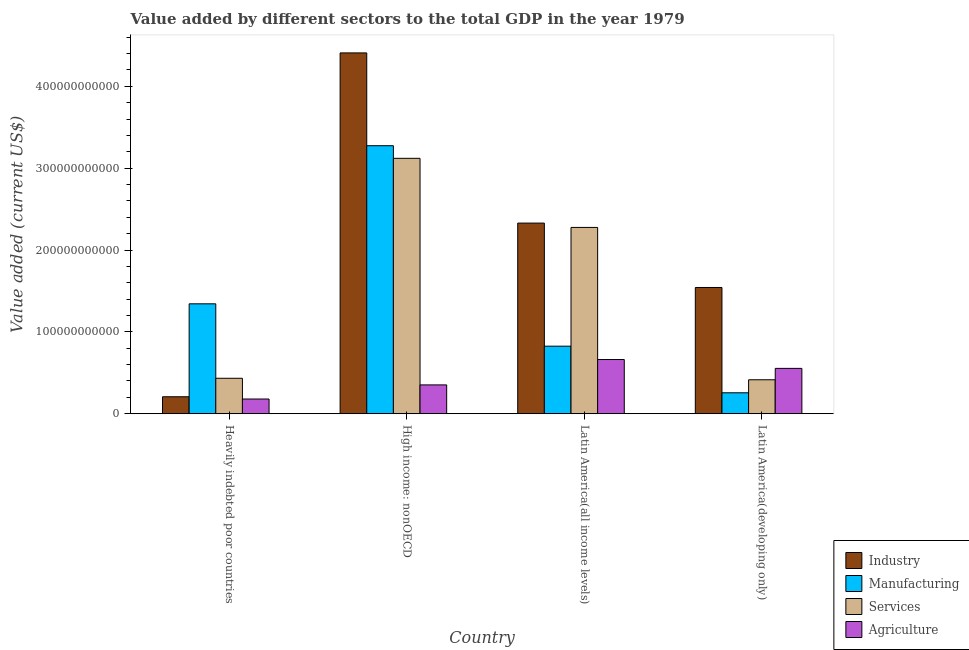How many different coloured bars are there?
Offer a terse response. 4. How many groups of bars are there?
Your answer should be very brief. 4. How many bars are there on the 4th tick from the left?
Offer a very short reply. 4. What is the label of the 3rd group of bars from the left?
Offer a terse response. Latin America(all income levels). What is the value added by industrial sector in Latin America(developing only)?
Your answer should be very brief. 1.54e+11. Across all countries, what is the maximum value added by manufacturing sector?
Your response must be concise. 3.27e+11. Across all countries, what is the minimum value added by agricultural sector?
Provide a short and direct response. 1.80e+1. In which country was the value added by industrial sector maximum?
Offer a very short reply. High income: nonOECD. In which country was the value added by industrial sector minimum?
Your response must be concise. Heavily indebted poor countries. What is the total value added by agricultural sector in the graph?
Provide a short and direct response. 1.75e+11. What is the difference between the value added by agricultural sector in High income: nonOECD and that in Latin America(developing only)?
Your answer should be compact. -2.02e+1. What is the difference between the value added by agricultural sector in Latin America(developing only) and the value added by services sector in High income: nonOECD?
Keep it short and to the point. -2.57e+11. What is the average value added by services sector per country?
Your response must be concise. 1.56e+11. What is the difference between the value added by services sector and value added by industrial sector in Heavily indebted poor countries?
Offer a very short reply. 2.26e+1. What is the ratio of the value added by services sector in Latin America(all income levels) to that in Latin America(developing only)?
Offer a very short reply. 5.48. Is the difference between the value added by services sector in High income: nonOECD and Latin America(all income levels) greater than the difference between the value added by industrial sector in High income: nonOECD and Latin America(all income levels)?
Offer a terse response. No. What is the difference between the highest and the second highest value added by manufacturing sector?
Your answer should be very brief. 1.93e+11. What is the difference between the highest and the lowest value added by industrial sector?
Offer a very short reply. 4.20e+11. In how many countries, is the value added by services sector greater than the average value added by services sector taken over all countries?
Ensure brevity in your answer.  2. Is it the case that in every country, the sum of the value added by agricultural sector and value added by manufacturing sector is greater than the sum of value added by services sector and value added by industrial sector?
Your answer should be compact. No. What does the 1st bar from the left in High income: nonOECD represents?
Keep it short and to the point. Industry. What does the 1st bar from the right in Latin America(developing only) represents?
Keep it short and to the point. Agriculture. Is it the case that in every country, the sum of the value added by industrial sector and value added by manufacturing sector is greater than the value added by services sector?
Offer a very short reply. Yes. Are all the bars in the graph horizontal?
Offer a terse response. No. How many countries are there in the graph?
Your response must be concise. 4. What is the difference between two consecutive major ticks on the Y-axis?
Keep it short and to the point. 1.00e+11. Does the graph contain any zero values?
Offer a very short reply. No. What is the title of the graph?
Provide a succinct answer. Value added by different sectors to the total GDP in the year 1979. Does "Burnt food" appear as one of the legend labels in the graph?
Your response must be concise. No. What is the label or title of the Y-axis?
Provide a succinct answer. Value added (current US$). What is the Value added (current US$) in Industry in Heavily indebted poor countries?
Your answer should be compact. 2.07e+1. What is the Value added (current US$) of Manufacturing in Heavily indebted poor countries?
Keep it short and to the point. 1.34e+11. What is the Value added (current US$) of Services in Heavily indebted poor countries?
Give a very brief answer. 4.33e+1. What is the Value added (current US$) in Agriculture in Heavily indebted poor countries?
Provide a succinct answer. 1.80e+1. What is the Value added (current US$) in Industry in High income: nonOECD?
Your answer should be very brief. 4.41e+11. What is the Value added (current US$) of Manufacturing in High income: nonOECD?
Provide a succinct answer. 3.27e+11. What is the Value added (current US$) of Services in High income: nonOECD?
Ensure brevity in your answer.  3.12e+11. What is the Value added (current US$) in Agriculture in High income: nonOECD?
Your answer should be very brief. 3.52e+1. What is the Value added (current US$) of Industry in Latin America(all income levels)?
Provide a short and direct response. 2.33e+11. What is the Value added (current US$) in Manufacturing in Latin America(all income levels)?
Your response must be concise. 8.25e+1. What is the Value added (current US$) in Services in Latin America(all income levels)?
Make the answer very short. 2.28e+11. What is the Value added (current US$) in Agriculture in Latin America(all income levels)?
Give a very brief answer. 6.62e+1. What is the Value added (current US$) of Industry in Latin America(developing only)?
Provide a short and direct response. 1.54e+11. What is the Value added (current US$) of Manufacturing in Latin America(developing only)?
Your answer should be compact. 2.56e+1. What is the Value added (current US$) of Services in Latin America(developing only)?
Keep it short and to the point. 4.15e+1. What is the Value added (current US$) of Agriculture in Latin America(developing only)?
Ensure brevity in your answer.  5.54e+1. Across all countries, what is the maximum Value added (current US$) of Industry?
Offer a very short reply. 4.41e+11. Across all countries, what is the maximum Value added (current US$) of Manufacturing?
Make the answer very short. 3.27e+11. Across all countries, what is the maximum Value added (current US$) of Services?
Keep it short and to the point. 3.12e+11. Across all countries, what is the maximum Value added (current US$) of Agriculture?
Your answer should be very brief. 6.62e+1. Across all countries, what is the minimum Value added (current US$) of Industry?
Your answer should be compact. 2.07e+1. Across all countries, what is the minimum Value added (current US$) in Manufacturing?
Give a very brief answer. 2.56e+1. Across all countries, what is the minimum Value added (current US$) of Services?
Ensure brevity in your answer.  4.15e+1. Across all countries, what is the minimum Value added (current US$) in Agriculture?
Make the answer very short. 1.80e+1. What is the total Value added (current US$) in Industry in the graph?
Give a very brief answer. 8.49e+11. What is the total Value added (current US$) of Manufacturing in the graph?
Your answer should be compact. 5.70e+11. What is the total Value added (current US$) in Services in the graph?
Your response must be concise. 6.25e+11. What is the total Value added (current US$) of Agriculture in the graph?
Your answer should be very brief. 1.75e+11. What is the difference between the Value added (current US$) in Industry in Heavily indebted poor countries and that in High income: nonOECD?
Keep it short and to the point. -4.20e+11. What is the difference between the Value added (current US$) of Manufacturing in Heavily indebted poor countries and that in High income: nonOECD?
Make the answer very short. -1.93e+11. What is the difference between the Value added (current US$) in Services in Heavily indebted poor countries and that in High income: nonOECD?
Offer a terse response. -2.69e+11. What is the difference between the Value added (current US$) in Agriculture in Heavily indebted poor countries and that in High income: nonOECD?
Make the answer very short. -1.72e+1. What is the difference between the Value added (current US$) in Industry in Heavily indebted poor countries and that in Latin America(all income levels)?
Make the answer very short. -2.12e+11. What is the difference between the Value added (current US$) in Manufacturing in Heavily indebted poor countries and that in Latin America(all income levels)?
Offer a very short reply. 5.18e+1. What is the difference between the Value added (current US$) of Services in Heavily indebted poor countries and that in Latin America(all income levels)?
Your answer should be very brief. -1.84e+11. What is the difference between the Value added (current US$) of Agriculture in Heavily indebted poor countries and that in Latin America(all income levels)?
Ensure brevity in your answer.  -4.82e+1. What is the difference between the Value added (current US$) of Industry in Heavily indebted poor countries and that in Latin America(developing only)?
Provide a short and direct response. -1.34e+11. What is the difference between the Value added (current US$) of Manufacturing in Heavily indebted poor countries and that in Latin America(developing only)?
Give a very brief answer. 1.09e+11. What is the difference between the Value added (current US$) of Services in Heavily indebted poor countries and that in Latin America(developing only)?
Ensure brevity in your answer.  1.83e+09. What is the difference between the Value added (current US$) of Agriculture in Heavily indebted poor countries and that in Latin America(developing only)?
Your answer should be very brief. -3.74e+1. What is the difference between the Value added (current US$) of Industry in High income: nonOECD and that in Latin America(all income levels)?
Your answer should be very brief. 2.08e+11. What is the difference between the Value added (current US$) in Manufacturing in High income: nonOECD and that in Latin America(all income levels)?
Give a very brief answer. 2.45e+11. What is the difference between the Value added (current US$) of Services in High income: nonOECD and that in Latin America(all income levels)?
Give a very brief answer. 8.44e+1. What is the difference between the Value added (current US$) of Agriculture in High income: nonOECD and that in Latin America(all income levels)?
Make the answer very short. -3.10e+1. What is the difference between the Value added (current US$) of Industry in High income: nonOECD and that in Latin America(developing only)?
Offer a terse response. 2.87e+11. What is the difference between the Value added (current US$) of Manufacturing in High income: nonOECD and that in Latin America(developing only)?
Your answer should be very brief. 3.02e+11. What is the difference between the Value added (current US$) in Services in High income: nonOECD and that in Latin America(developing only)?
Give a very brief answer. 2.71e+11. What is the difference between the Value added (current US$) in Agriculture in High income: nonOECD and that in Latin America(developing only)?
Make the answer very short. -2.02e+1. What is the difference between the Value added (current US$) in Industry in Latin America(all income levels) and that in Latin America(developing only)?
Keep it short and to the point. 7.87e+1. What is the difference between the Value added (current US$) of Manufacturing in Latin America(all income levels) and that in Latin America(developing only)?
Provide a short and direct response. 5.69e+1. What is the difference between the Value added (current US$) in Services in Latin America(all income levels) and that in Latin America(developing only)?
Offer a terse response. 1.86e+11. What is the difference between the Value added (current US$) in Agriculture in Latin America(all income levels) and that in Latin America(developing only)?
Keep it short and to the point. 1.08e+1. What is the difference between the Value added (current US$) in Industry in Heavily indebted poor countries and the Value added (current US$) in Manufacturing in High income: nonOECD?
Make the answer very short. -3.07e+11. What is the difference between the Value added (current US$) of Industry in Heavily indebted poor countries and the Value added (current US$) of Services in High income: nonOECD?
Offer a very short reply. -2.91e+11. What is the difference between the Value added (current US$) in Industry in Heavily indebted poor countries and the Value added (current US$) in Agriculture in High income: nonOECD?
Offer a terse response. -1.45e+1. What is the difference between the Value added (current US$) of Manufacturing in Heavily indebted poor countries and the Value added (current US$) of Services in High income: nonOECD?
Provide a succinct answer. -1.78e+11. What is the difference between the Value added (current US$) in Manufacturing in Heavily indebted poor countries and the Value added (current US$) in Agriculture in High income: nonOECD?
Keep it short and to the point. 9.91e+1. What is the difference between the Value added (current US$) in Services in Heavily indebted poor countries and the Value added (current US$) in Agriculture in High income: nonOECD?
Offer a very short reply. 8.10e+09. What is the difference between the Value added (current US$) in Industry in Heavily indebted poor countries and the Value added (current US$) in Manufacturing in Latin America(all income levels)?
Ensure brevity in your answer.  -6.18e+1. What is the difference between the Value added (current US$) in Industry in Heavily indebted poor countries and the Value added (current US$) in Services in Latin America(all income levels)?
Provide a short and direct response. -2.07e+11. What is the difference between the Value added (current US$) in Industry in Heavily indebted poor countries and the Value added (current US$) in Agriculture in Latin America(all income levels)?
Provide a succinct answer. -4.55e+1. What is the difference between the Value added (current US$) in Manufacturing in Heavily indebted poor countries and the Value added (current US$) in Services in Latin America(all income levels)?
Your response must be concise. -9.33e+1. What is the difference between the Value added (current US$) in Manufacturing in Heavily indebted poor countries and the Value added (current US$) in Agriculture in Latin America(all income levels)?
Offer a very short reply. 6.81e+1. What is the difference between the Value added (current US$) in Services in Heavily indebted poor countries and the Value added (current US$) in Agriculture in Latin America(all income levels)?
Make the answer very short. -2.29e+1. What is the difference between the Value added (current US$) in Industry in Heavily indebted poor countries and the Value added (current US$) in Manufacturing in Latin America(developing only)?
Your answer should be very brief. -4.86e+09. What is the difference between the Value added (current US$) in Industry in Heavily indebted poor countries and the Value added (current US$) in Services in Latin America(developing only)?
Make the answer very short. -2.08e+1. What is the difference between the Value added (current US$) of Industry in Heavily indebted poor countries and the Value added (current US$) of Agriculture in Latin America(developing only)?
Make the answer very short. -3.47e+1. What is the difference between the Value added (current US$) of Manufacturing in Heavily indebted poor countries and the Value added (current US$) of Services in Latin America(developing only)?
Ensure brevity in your answer.  9.28e+1. What is the difference between the Value added (current US$) of Manufacturing in Heavily indebted poor countries and the Value added (current US$) of Agriculture in Latin America(developing only)?
Make the answer very short. 7.89e+1. What is the difference between the Value added (current US$) in Services in Heavily indebted poor countries and the Value added (current US$) in Agriculture in Latin America(developing only)?
Your answer should be compact. -1.21e+1. What is the difference between the Value added (current US$) in Industry in High income: nonOECD and the Value added (current US$) in Manufacturing in Latin America(all income levels)?
Ensure brevity in your answer.  3.58e+11. What is the difference between the Value added (current US$) of Industry in High income: nonOECD and the Value added (current US$) of Services in Latin America(all income levels)?
Your answer should be compact. 2.13e+11. What is the difference between the Value added (current US$) in Industry in High income: nonOECD and the Value added (current US$) in Agriculture in Latin America(all income levels)?
Make the answer very short. 3.75e+11. What is the difference between the Value added (current US$) in Manufacturing in High income: nonOECD and the Value added (current US$) in Services in Latin America(all income levels)?
Your answer should be compact. 9.98e+1. What is the difference between the Value added (current US$) in Manufacturing in High income: nonOECD and the Value added (current US$) in Agriculture in Latin America(all income levels)?
Make the answer very short. 2.61e+11. What is the difference between the Value added (current US$) of Services in High income: nonOECD and the Value added (current US$) of Agriculture in Latin America(all income levels)?
Provide a succinct answer. 2.46e+11. What is the difference between the Value added (current US$) of Industry in High income: nonOECD and the Value added (current US$) of Manufacturing in Latin America(developing only)?
Offer a very short reply. 4.15e+11. What is the difference between the Value added (current US$) in Industry in High income: nonOECD and the Value added (current US$) in Services in Latin America(developing only)?
Offer a terse response. 3.99e+11. What is the difference between the Value added (current US$) of Industry in High income: nonOECD and the Value added (current US$) of Agriculture in Latin America(developing only)?
Your answer should be very brief. 3.85e+11. What is the difference between the Value added (current US$) of Manufacturing in High income: nonOECD and the Value added (current US$) of Services in Latin America(developing only)?
Your answer should be compact. 2.86e+11. What is the difference between the Value added (current US$) of Manufacturing in High income: nonOECD and the Value added (current US$) of Agriculture in Latin America(developing only)?
Offer a terse response. 2.72e+11. What is the difference between the Value added (current US$) in Services in High income: nonOECD and the Value added (current US$) in Agriculture in Latin America(developing only)?
Give a very brief answer. 2.57e+11. What is the difference between the Value added (current US$) of Industry in Latin America(all income levels) and the Value added (current US$) of Manufacturing in Latin America(developing only)?
Offer a very short reply. 2.07e+11. What is the difference between the Value added (current US$) of Industry in Latin America(all income levels) and the Value added (current US$) of Services in Latin America(developing only)?
Give a very brief answer. 1.91e+11. What is the difference between the Value added (current US$) of Industry in Latin America(all income levels) and the Value added (current US$) of Agriculture in Latin America(developing only)?
Offer a very short reply. 1.78e+11. What is the difference between the Value added (current US$) of Manufacturing in Latin America(all income levels) and the Value added (current US$) of Services in Latin America(developing only)?
Provide a short and direct response. 4.10e+1. What is the difference between the Value added (current US$) in Manufacturing in Latin America(all income levels) and the Value added (current US$) in Agriculture in Latin America(developing only)?
Ensure brevity in your answer.  2.71e+1. What is the difference between the Value added (current US$) in Services in Latin America(all income levels) and the Value added (current US$) in Agriculture in Latin America(developing only)?
Offer a terse response. 1.72e+11. What is the average Value added (current US$) of Industry per country?
Your answer should be very brief. 2.12e+11. What is the average Value added (current US$) in Manufacturing per country?
Make the answer very short. 1.42e+11. What is the average Value added (current US$) of Services per country?
Give a very brief answer. 1.56e+11. What is the average Value added (current US$) in Agriculture per country?
Your answer should be very brief. 4.37e+1. What is the difference between the Value added (current US$) in Industry and Value added (current US$) in Manufacturing in Heavily indebted poor countries?
Offer a terse response. -1.14e+11. What is the difference between the Value added (current US$) in Industry and Value added (current US$) in Services in Heavily indebted poor countries?
Offer a very short reply. -2.26e+1. What is the difference between the Value added (current US$) in Industry and Value added (current US$) in Agriculture in Heavily indebted poor countries?
Make the answer very short. 2.74e+09. What is the difference between the Value added (current US$) of Manufacturing and Value added (current US$) of Services in Heavily indebted poor countries?
Give a very brief answer. 9.10e+1. What is the difference between the Value added (current US$) of Manufacturing and Value added (current US$) of Agriculture in Heavily indebted poor countries?
Provide a succinct answer. 1.16e+11. What is the difference between the Value added (current US$) in Services and Value added (current US$) in Agriculture in Heavily indebted poor countries?
Offer a very short reply. 2.53e+1. What is the difference between the Value added (current US$) of Industry and Value added (current US$) of Manufacturing in High income: nonOECD?
Your answer should be very brief. 1.13e+11. What is the difference between the Value added (current US$) of Industry and Value added (current US$) of Services in High income: nonOECD?
Your answer should be very brief. 1.29e+11. What is the difference between the Value added (current US$) in Industry and Value added (current US$) in Agriculture in High income: nonOECD?
Provide a short and direct response. 4.06e+11. What is the difference between the Value added (current US$) of Manufacturing and Value added (current US$) of Services in High income: nonOECD?
Provide a short and direct response. 1.54e+1. What is the difference between the Value added (current US$) in Manufacturing and Value added (current US$) in Agriculture in High income: nonOECD?
Give a very brief answer. 2.92e+11. What is the difference between the Value added (current US$) of Services and Value added (current US$) of Agriculture in High income: nonOECD?
Ensure brevity in your answer.  2.77e+11. What is the difference between the Value added (current US$) of Industry and Value added (current US$) of Manufacturing in Latin America(all income levels)?
Offer a very short reply. 1.50e+11. What is the difference between the Value added (current US$) in Industry and Value added (current US$) in Services in Latin America(all income levels)?
Ensure brevity in your answer.  5.30e+09. What is the difference between the Value added (current US$) in Industry and Value added (current US$) in Agriculture in Latin America(all income levels)?
Make the answer very short. 1.67e+11. What is the difference between the Value added (current US$) of Manufacturing and Value added (current US$) of Services in Latin America(all income levels)?
Provide a succinct answer. -1.45e+11. What is the difference between the Value added (current US$) in Manufacturing and Value added (current US$) in Agriculture in Latin America(all income levels)?
Your answer should be very brief. 1.63e+1. What is the difference between the Value added (current US$) in Services and Value added (current US$) in Agriculture in Latin America(all income levels)?
Offer a terse response. 1.61e+11. What is the difference between the Value added (current US$) of Industry and Value added (current US$) of Manufacturing in Latin America(developing only)?
Keep it short and to the point. 1.29e+11. What is the difference between the Value added (current US$) in Industry and Value added (current US$) in Services in Latin America(developing only)?
Make the answer very short. 1.13e+11. What is the difference between the Value added (current US$) in Industry and Value added (current US$) in Agriculture in Latin America(developing only)?
Keep it short and to the point. 9.88e+1. What is the difference between the Value added (current US$) in Manufacturing and Value added (current US$) in Services in Latin America(developing only)?
Provide a succinct answer. -1.59e+1. What is the difference between the Value added (current US$) of Manufacturing and Value added (current US$) of Agriculture in Latin America(developing only)?
Offer a very short reply. -2.98e+1. What is the difference between the Value added (current US$) of Services and Value added (current US$) of Agriculture in Latin America(developing only)?
Provide a short and direct response. -1.39e+1. What is the ratio of the Value added (current US$) of Industry in Heavily indebted poor countries to that in High income: nonOECD?
Provide a succinct answer. 0.05. What is the ratio of the Value added (current US$) of Manufacturing in Heavily indebted poor countries to that in High income: nonOECD?
Provide a short and direct response. 0.41. What is the ratio of the Value added (current US$) in Services in Heavily indebted poor countries to that in High income: nonOECD?
Provide a short and direct response. 0.14. What is the ratio of the Value added (current US$) of Agriculture in Heavily indebted poor countries to that in High income: nonOECD?
Ensure brevity in your answer.  0.51. What is the ratio of the Value added (current US$) of Industry in Heavily indebted poor countries to that in Latin America(all income levels)?
Offer a terse response. 0.09. What is the ratio of the Value added (current US$) in Manufacturing in Heavily indebted poor countries to that in Latin America(all income levels)?
Ensure brevity in your answer.  1.63. What is the ratio of the Value added (current US$) in Services in Heavily indebted poor countries to that in Latin America(all income levels)?
Your answer should be very brief. 0.19. What is the ratio of the Value added (current US$) in Agriculture in Heavily indebted poor countries to that in Latin America(all income levels)?
Give a very brief answer. 0.27. What is the ratio of the Value added (current US$) in Industry in Heavily indebted poor countries to that in Latin America(developing only)?
Keep it short and to the point. 0.13. What is the ratio of the Value added (current US$) of Manufacturing in Heavily indebted poor countries to that in Latin America(developing only)?
Offer a very short reply. 5.25. What is the ratio of the Value added (current US$) of Services in Heavily indebted poor countries to that in Latin America(developing only)?
Keep it short and to the point. 1.04. What is the ratio of the Value added (current US$) of Agriculture in Heavily indebted poor countries to that in Latin America(developing only)?
Offer a very short reply. 0.32. What is the ratio of the Value added (current US$) in Industry in High income: nonOECD to that in Latin America(all income levels)?
Keep it short and to the point. 1.89. What is the ratio of the Value added (current US$) in Manufacturing in High income: nonOECD to that in Latin America(all income levels)?
Offer a terse response. 3.97. What is the ratio of the Value added (current US$) of Services in High income: nonOECD to that in Latin America(all income levels)?
Provide a short and direct response. 1.37. What is the ratio of the Value added (current US$) of Agriculture in High income: nonOECD to that in Latin America(all income levels)?
Offer a very short reply. 0.53. What is the ratio of the Value added (current US$) in Industry in High income: nonOECD to that in Latin America(developing only)?
Give a very brief answer. 2.86. What is the ratio of the Value added (current US$) in Manufacturing in High income: nonOECD to that in Latin America(developing only)?
Provide a succinct answer. 12.79. What is the ratio of the Value added (current US$) of Services in High income: nonOECD to that in Latin America(developing only)?
Provide a succinct answer. 7.52. What is the ratio of the Value added (current US$) of Agriculture in High income: nonOECD to that in Latin America(developing only)?
Offer a very short reply. 0.64. What is the ratio of the Value added (current US$) in Industry in Latin America(all income levels) to that in Latin America(developing only)?
Provide a succinct answer. 1.51. What is the ratio of the Value added (current US$) in Manufacturing in Latin America(all income levels) to that in Latin America(developing only)?
Give a very brief answer. 3.22. What is the ratio of the Value added (current US$) of Services in Latin America(all income levels) to that in Latin America(developing only)?
Your response must be concise. 5.48. What is the ratio of the Value added (current US$) of Agriculture in Latin America(all income levels) to that in Latin America(developing only)?
Offer a terse response. 1.2. What is the difference between the highest and the second highest Value added (current US$) of Industry?
Give a very brief answer. 2.08e+11. What is the difference between the highest and the second highest Value added (current US$) in Manufacturing?
Offer a very short reply. 1.93e+11. What is the difference between the highest and the second highest Value added (current US$) of Services?
Keep it short and to the point. 8.44e+1. What is the difference between the highest and the second highest Value added (current US$) in Agriculture?
Give a very brief answer. 1.08e+1. What is the difference between the highest and the lowest Value added (current US$) in Industry?
Give a very brief answer. 4.20e+11. What is the difference between the highest and the lowest Value added (current US$) of Manufacturing?
Keep it short and to the point. 3.02e+11. What is the difference between the highest and the lowest Value added (current US$) of Services?
Provide a short and direct response. 2.71e+11. What is the difference between the highest and the lowest Value added (current US$) of Agriculture?
Keep it short and to the point. 4.82e+1. 